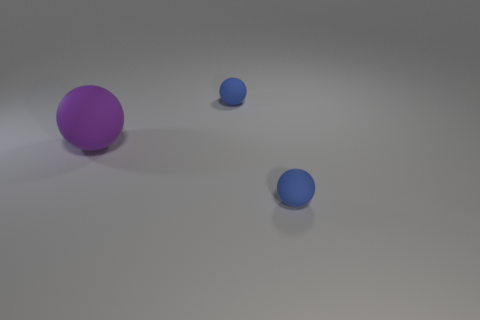Is the number of small cyan balls greater than the number of spheres?
Offer a very short reply. No. Is the blue thing in front of the big purple rubber sphere made of the same material as the thing that is behind the purple rubber thing?
Give a very brief answer. Yes. Is the number of balls less than the number of purple things?
Provide a succinct answer. No. There is a blue matte ball that is behind the purple thing; are there any balls that are on the left side of it?
Make the answer very short. Yes. There is a small blue rubber thing that is right of the blue object that is behind the purple matte object; is there a small blue sphere behind it?
Offer a very short reply. Yes. There is a blue matte object behind the purple matte sphere; is its shape the same as the small thing that is in front of the purple rubber ball?
Your answer should be very brief. Yes. Are there fewer rubber balls that are left of the large purple rubber object than tiny objects?
Make the answer very short. Yes. There is a object that is left of the small rubber sphere left of the small object that is in front of the large purple thing; how big is it?
Your answer should be very brief. Large. Do the small blue sphere that is behind the big purple matte ball and the purple thing have the same material?
Ensure brevity in your answer.  Yes. Are there any other things that have the same shape as the purple matte thing?
Offer a terse response. Yes. 